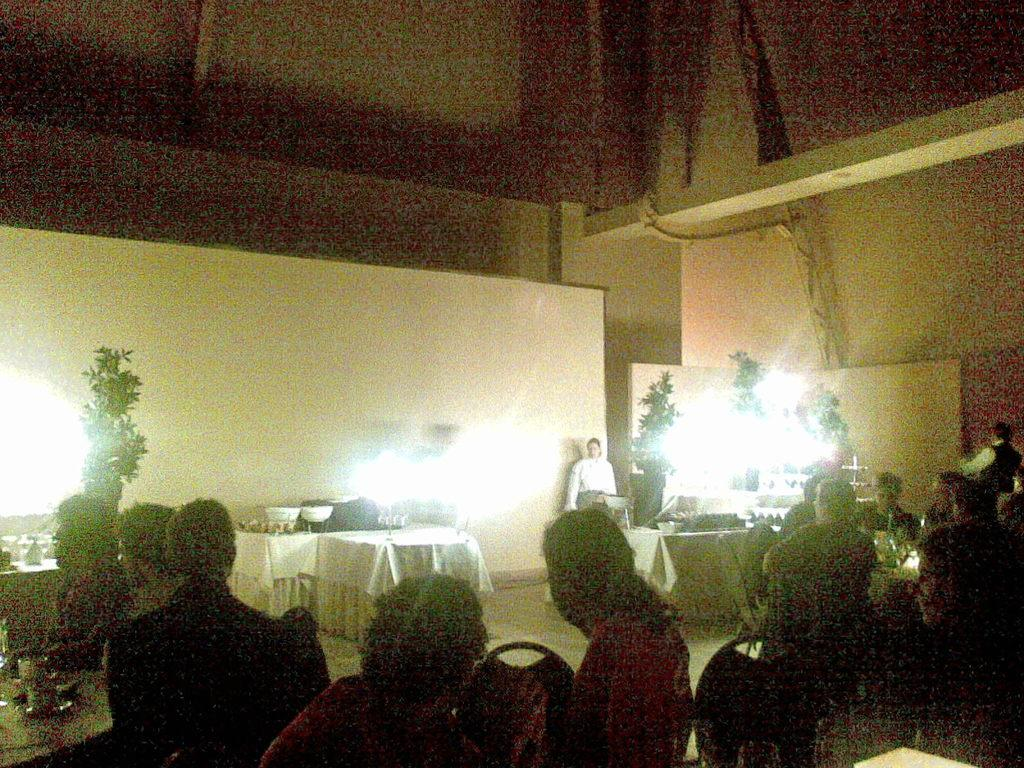What are the persons in the image doing? The persons in the image are sitting on chairs. How are the chairs arranged in the image? The chairs are arranged on the floor. What else is arranged on the floor in the image? There are tables arranged on the floor. What can be seen in the background of the image? There are plants, lights, and a person in the background. What is the background of the image made up of? The background of the image includes a wall. What is the coefficient of friction between the chairs and the floor in the image? The image does not provide information about the coefficient of friction between the chairs and the floor. How many mines are present in the image? There are no mines present in the image. 